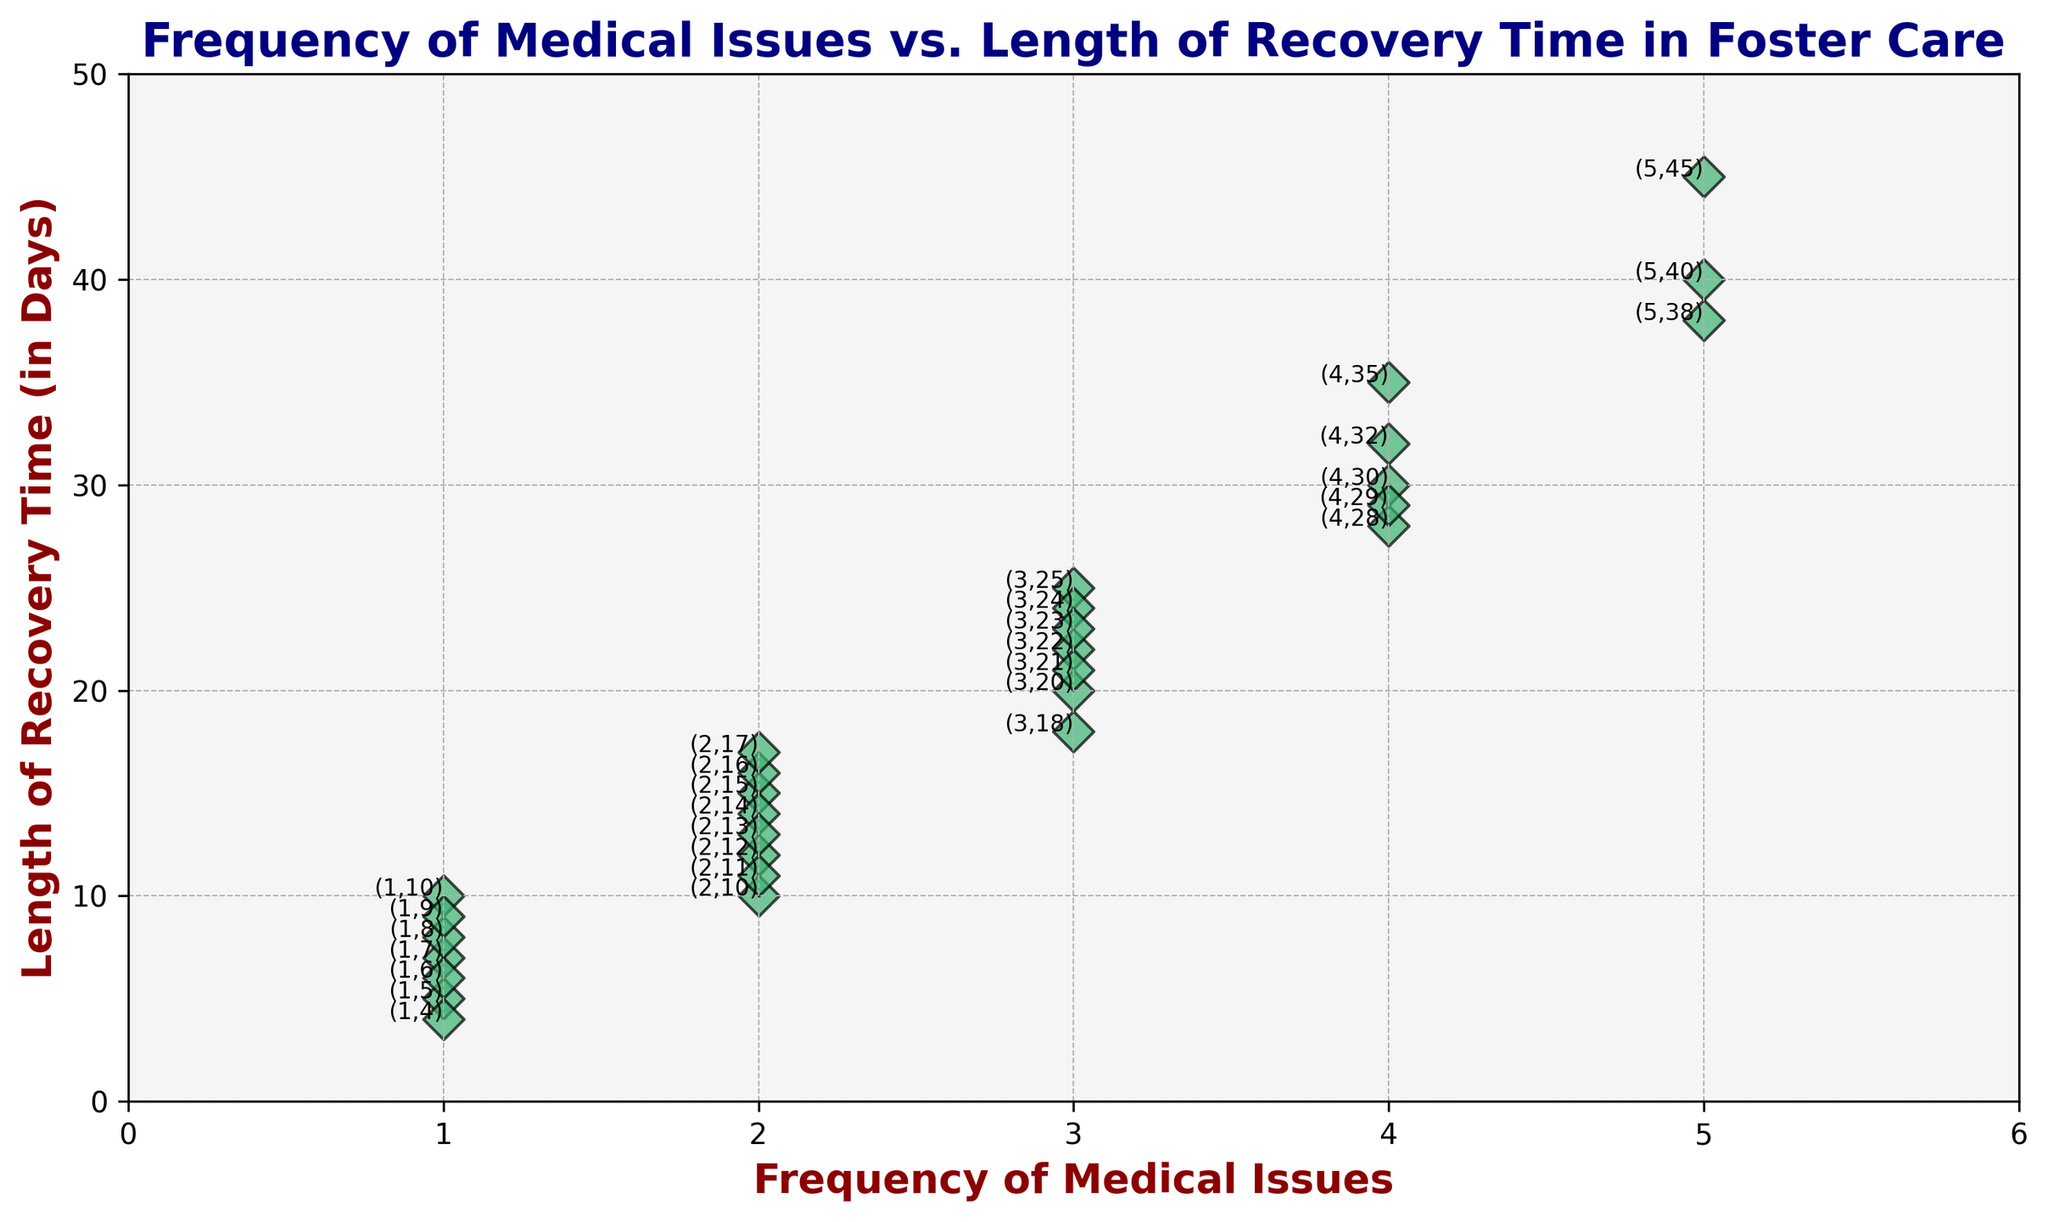What's the highest frequency of medical issues observed? The figure shows multiple data points with varying frequencies of medical issues. To find the highest frequency, identify the maximum value on the x-axis.
Answer: 5 Which data point has the longest recovery time? To locate the data point with the longest recovery time, find the point that is highest on the y-axis. The data label for that point will indicate its frequency and recovery time.
Answer: (5, 45) How does the average recovery time for cases with 2 medical issues compare to cases with 4 medical issues? First, tally the recovery times for points with 2 medical issues: (15 + 12 + 14 + 10 + 13 + 16 + 17) = 97. Calculate the average: 97/7 ≈ 13.86 days. Then, tally the recovery times for points with 4 medical issues: (30 + 35 + 28 + 32 + 29) = 154. Calculate the average: 154/5 = 30.8 days. Compare the two averages.
Answer: 13.86 days vs 30.8 days Which frequency of medical issues has the most varied recovery times? To determine this, observe the range (difference between the maximum and minimum values) of recovery times for each frequency. The widest spread indicates the most variation.
Answer: 2 medical issues Is there a general trend between the frequency of medical issues and length of recovery time? Look for overall patterns in the scatter plot. As the frequency of medical issues on the x-axis increases, note whether the points generally move upwards on the y-axis, indicating longer recovery times.
Answer: Yes, more issues generally lead to longer recovery times What is the shortest recovery time recorded in the plot? Find the lowest point on the y-axis. The data label will indicate the frequency and corresponding shortest recovery time.
Answer: 4 days How many data points appear to have a recovery time of less than 10 days? Count the number of points that fall below the 10-day mark on the y-axis.
Answer: 8 For cases with 3 medical issues, what is the average recovery time? Identify points with 3 issues: (25, 20, 22, 18, 24, 21, 23). Sum the recovery times (25 + 20 + 22 + 18 + 24 + 21 + 23) = 153. Average: 153/7 ≈ 21.86 days.
Answer: 21.86 days Which specific case has 4 medical issues and a recovery time near the middle of the observed range for this frequency? For 4 medical issues, consider recovery times (30, 35, 28, 32, 29). The median value is determined by sorting these (28, 29, 30, 32, 35). The middle value is 30.
Answer: (4, 30) How do the scatter points' colors and markers help distinguish the data points? The scatter points have a consistent color (mediumseagreen) and diamond-shaped markers with black edges, making them easily distinguishable against the background. The labels additionally clarify each data point's specific values.
Answer: Clear differentiation with color and shape 